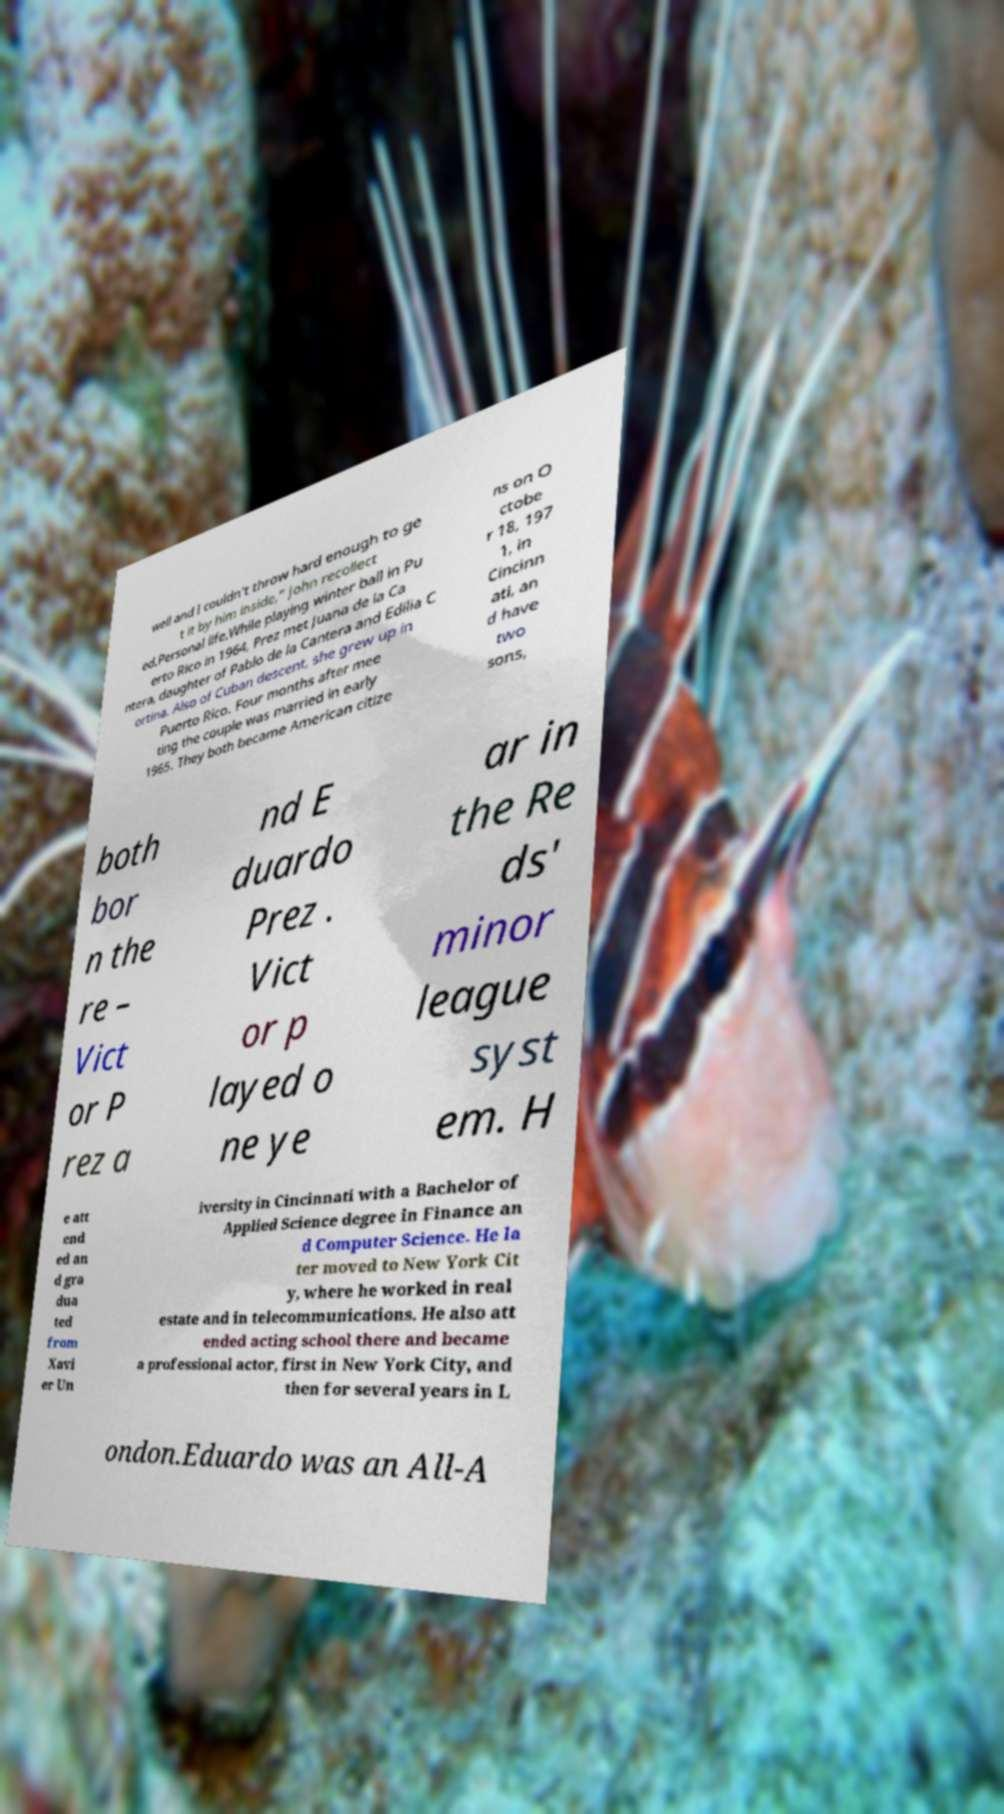Can you read and provide the text displayed in the image?This photo seems to have some interesting text. Can you extract and type it out for me? well and I couldn't throw hard enough to ge t it by him inside," John recollect ed.Personal life.While playing winter ball in Pu erto Rico in 1964, Prez met Juana de la Ca ntera, daughter of Pablo de la Cantera and Edilia C ortina. Also of Cuban descent, she grew up in Puerto Rico. Four months after mee ting the couple was married in early 1965. They both became American citize ns on O ctobe r 18, 197 1, in Cincinn ati, an d have two sons, both bor n the re – Vict or P rez a nd E duardo Prez . Vict or p layed o ne ye ar in the Re ds' minor league syst em. H e att end ed an d gra dua ted from Xavi er Un iversity in Cincinnati with a Bachelor of Applied Science degree in Finance an d Computer Science. He la ter moved to New York Cit y, where he worked in real estate and in telecommunications. He also att ended acting school there and became a professional actor, first in New York City, and then for several years in L ondon.Eduardo was an All-A 